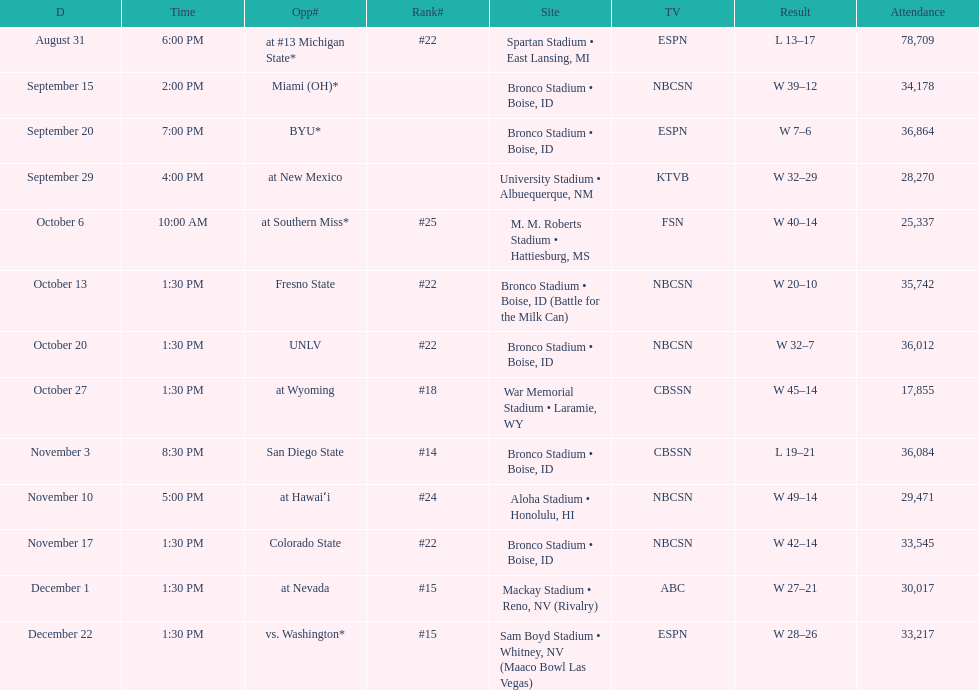What was there top ranked position of the season? #14. 